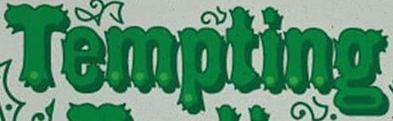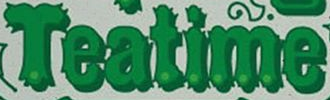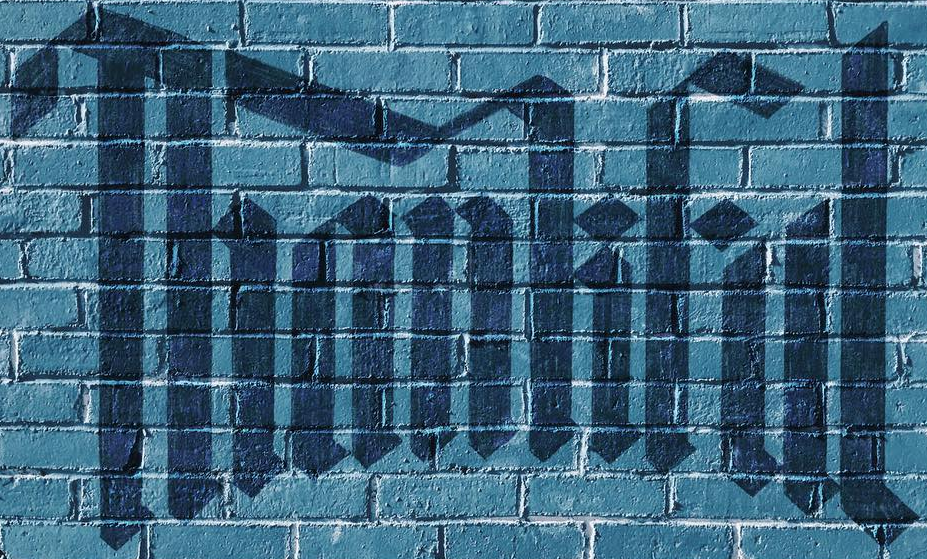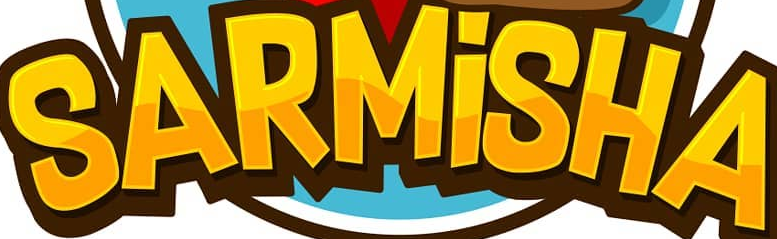Read the text content from these images in order, separated by a semicolon. Tempting; Teatime; Thankful; SARMİSHA 